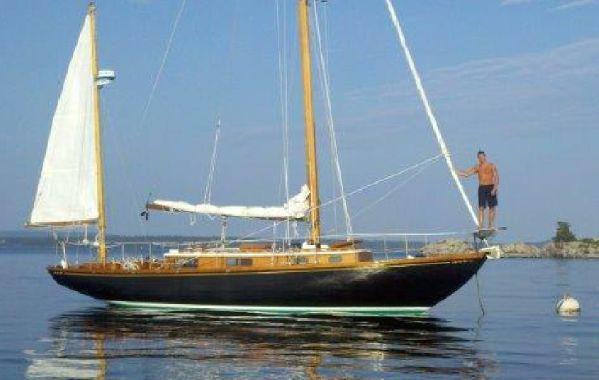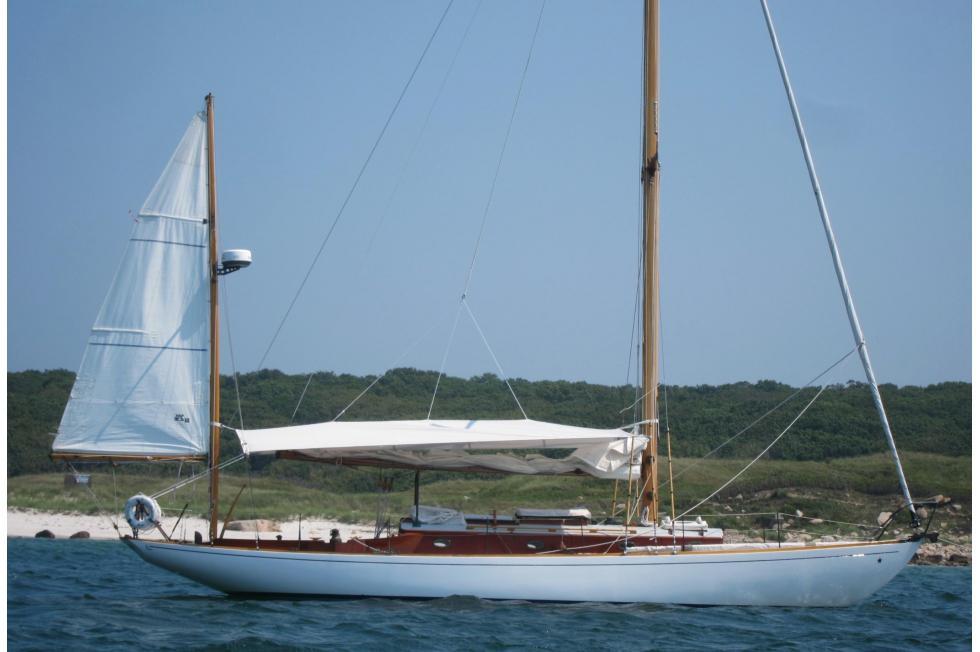The first image is the image on the left, the second image is the image on the right. Given the left and right images, does the statement "An image shows a dark-bodied boat with its main sail still furled." hold true? Answer yes or no. Yes. 